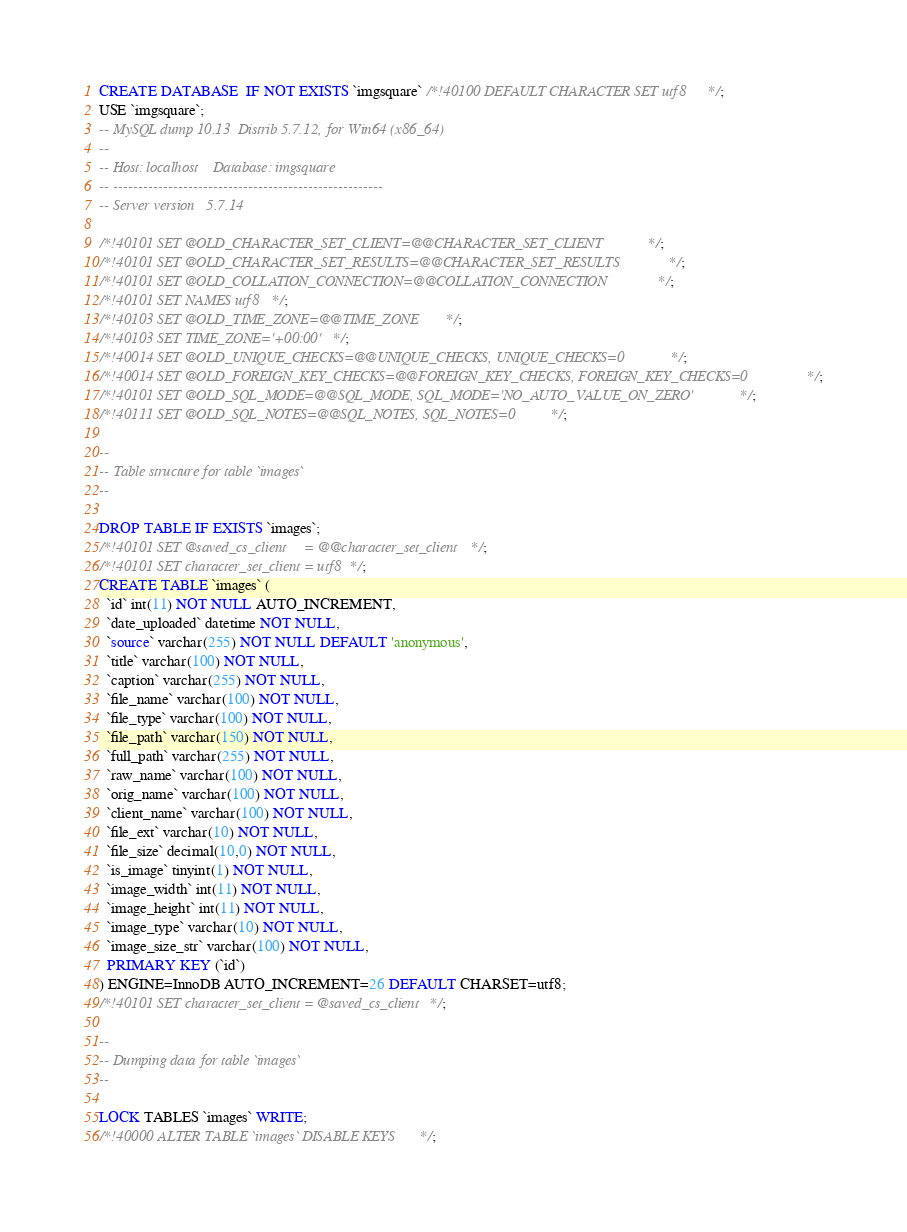<code> <loc_0><loc_0><loc_500><loc_500><_SQL_>CREATE DATABASE  IF NOT EXISTS `imgsquare` /*!40100 DEFAULT CHARACTER SET utf8 */;
USE `imgsquare`;
-- MySQL dump 10.13  Distrib 5.7.12, for Win64 (x86_64)
--
-- Host: localhost    Database: imgsquare
-- ------------------------------------------------------
-- Server version	5.7.14

/*!40101 SET @OLD_CHARACTER_SET_CLIENT=@@CHARACTER_SET_CLIENT */;
/*!40101 SET @OLD_CHARACTER_SET_RESULTS=@@CHARACTER_SET_RESULTS */;
/*!40101 SET @OLD_COLLATION_CONNECTION=@@COLLATION_CONNECTION */;
/*!40101 SET NAMES utf8 */;
/*!40103 SET @OLD_TIME_ZONE=@@TIME_ZONE */;
/*!40103 SET TIME_ZONE='+00:00' */;
/*!40014 SET @OLD_UNIQUE_CHECKS=@@UNIQUE_CHECKS, UNIQUE_CHECKS=0 */;
/*!40014 SET @OLD_FOREIGN_KEY_CHECKS=@@FOREIGN_KEY_CHECKS, FOREIGN_KEY_CHECKS=0 */;
/*!40101 SET @OLD_SQL_MODE=@@SQL_MODE, SQL_MODE='NO_AUTO_VALUE_ON_ZERO' */;
/*!40111 SET @OLD_SQL_NOTES=@@SQL_NOTES, SQL_NOTES=0 */;

--
-- Table structure for table `images`
--

DROP TABLE IF EXISTS `images`;
/*!40101 SET @saved_cs_client     = @@character_set_client */;
/*!40101 SET character_set_client = utf8 */;
CREATE TABLE `images` (
  `id` int(11) NOT NULL AUTO_INCREMENT,
  `date_uploaded` datetime NOT NULL,
  `source` varchar(255) NOT NULL DEFAULT 'anonymous',
  `title` varchar(100) NOT NULL,
  `caption` varchar(255) NOT NULL,
  `file_name` varchar(100) NOT NULL,
  `file_type` varchar(100) NOT NULL,
  `file_path` varchar(150) NOT NULL,
  `full_path` varchar(255) NOT NULL,
  `raw_name` varchar(100) NOT NULL,
  `orig_name` varchar(100) NOT NULL,
  `client_name` varchar(100) NOT NULL,
  `file_ext` varchar(10) NOT NULL,
  `file_size` decimal(10,0) NOT NULL,
  `is_image` tinyint(1) NOT NULL,
  `image_width` int(11) NOT NULL,
  `image_height` int(11) NOT NULL,
  `image_type` varchar(10) NOT NULL,
  `image_size_str` varchar(100) NOT NULL,
  PRIMARY KEY (`id`)
) ENGINE=InnoDB AUTO_INCREMENT=26 DEFAULT CHARSET=utf8;
/*!40101 SET character_set_client = @saved_cs_client */;

--
-- Dumping data for table `images`
--

LOCK TABLES `images` WRITE;
/*!40000 ALTER TABLE `images` DISABLE KEYS */;</code> 